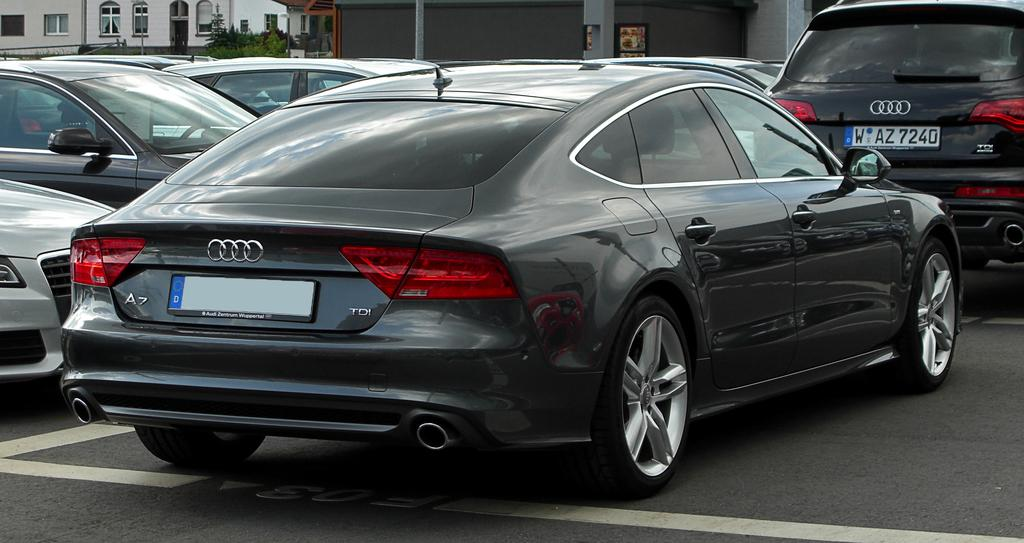<image>
Render a clear and concise summary of the photo. An Audi with a blank license plate is parked in a lot. 